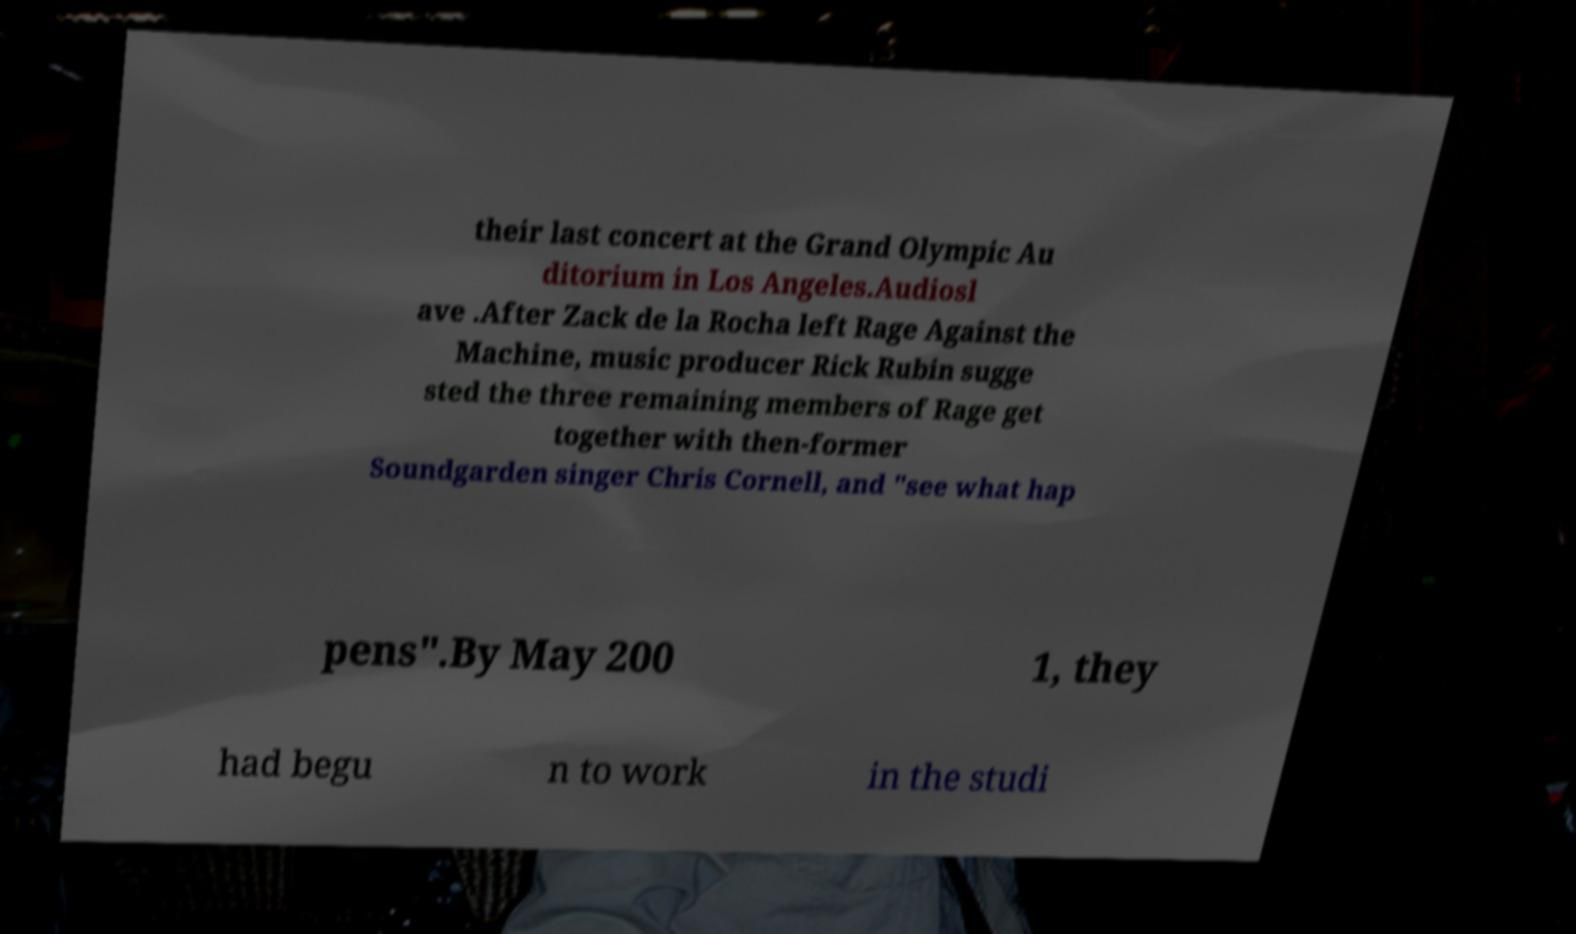Can you read and provide the text displayed in the image?This photo seems to have some interesting text. Can you extract and type it out for me? their last concert at the Grand Olympic Au ditorium in Los Angeles.Audiosl ave .After Zack de la Rocha left Rage Against the Machine, music producer Rick Rubin sugge sted the three remaining members of Rage get together with then-former Soundgarden singer Chris Cornell, and "see what hap pens".By May 200 1, they had begu n to work in the studi 